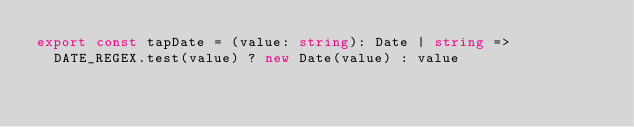Convert code to text. <code><loc_0><loc_0><loc_500><loc_500><_TypeScript_>export const tapDate = (value: string): Date | string =>
  DATE_REGEX.test(value) ? new Date(value) : value
</code> 